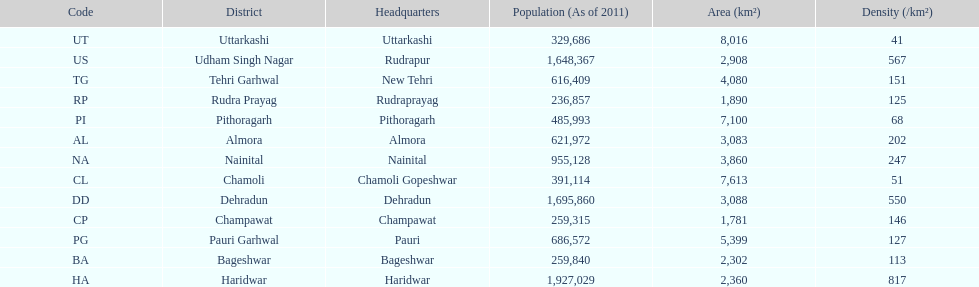Tell me a district that only has a density of 51. Chamoli. Parse the table in full. {'header': ['Code', 'District', 'Headquarters', 'Population (As of 2011)', 'Area (km²)', 'Density (/km²)'], 'rows': [['UT', 'Uttarkashi', 'Uttarkashi', '329,686', '8,016', '41'], ['US', 'Udham Singh Nagar', 'Rudrapur', '1,648,367', '2,908', '567'], ['TG', 'Tehri Garhwal', 'New Tehri', '616,409', '4,080', '151'], ['RP', 'Rudra Prayag', 'Rudraprayag', '236,857', '1,890', '125'], ['PI', 'Pithoragarh', 'Pithoragarh', '485,993', '7,100', '68'], ['AL', 'Almora', 'Almora', '621,972', '3,083', '202'], ['NA', 'Nainital', 'Nainital', '955,128', '3,860', '247'], ['CL', 'Chamoli', 'Chamoli Gopeshwar', '391,114', '7,613', '51'], ['DD', 'Dehradun', 'Dehradun', '1,695,860', '3,088', '550'], ['CP', 'Champawat', 'Champawat', '259,315', '1,781', '146'], ['PG', 'Pauri Garhwal', 'Pauri', '686,572', '5,399', '127'], ['BA', 'Bageshwar', 'Bageshwar', '259,840', '2,302', '113'], ['HA', 'Haridwar', 'Haridwar', '1,927,029', '2,360', '817']]} 